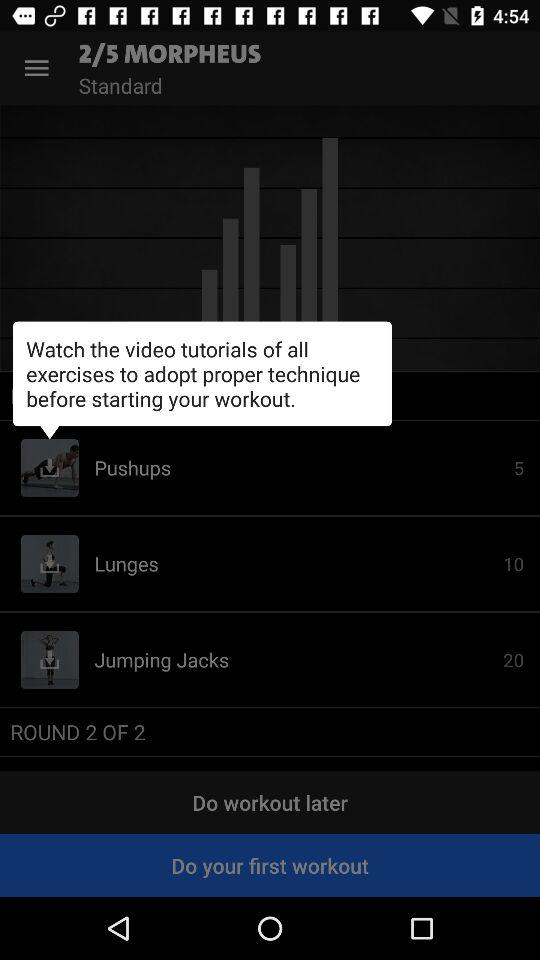How many sets of exercises are in this workout?
Answer the question using a single word or phrase. 2 